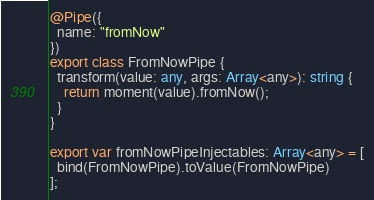Convert code to text. <code><loc_0><loc_0><loc_500><loc_500><_TypeScript_>
@Pipe({
  name: "fromNow"
})
export class FromNowPipe {
  transform(value: any, args: Array<any>): string {
    return moment(value).fromNow();
  }
}

export var fromNowPipeInjectables: Array<any> = [
  bind(FromNowPipe).toValue(FromNowPipe)
];

</code> 